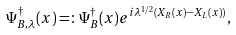<formula> <loc_0><loc_0><loc_500><loc_500>\Psi ^ { \dagger } _ { B , \lambda } ( x ) = \colon \Psi ^ { \dagger } _ { B } ( x ) e ^ { i \lambda ^ { 1 / 2 } ( X _ { R } ( x ) - X _ { L } ( x ) ) } ,</formula> 